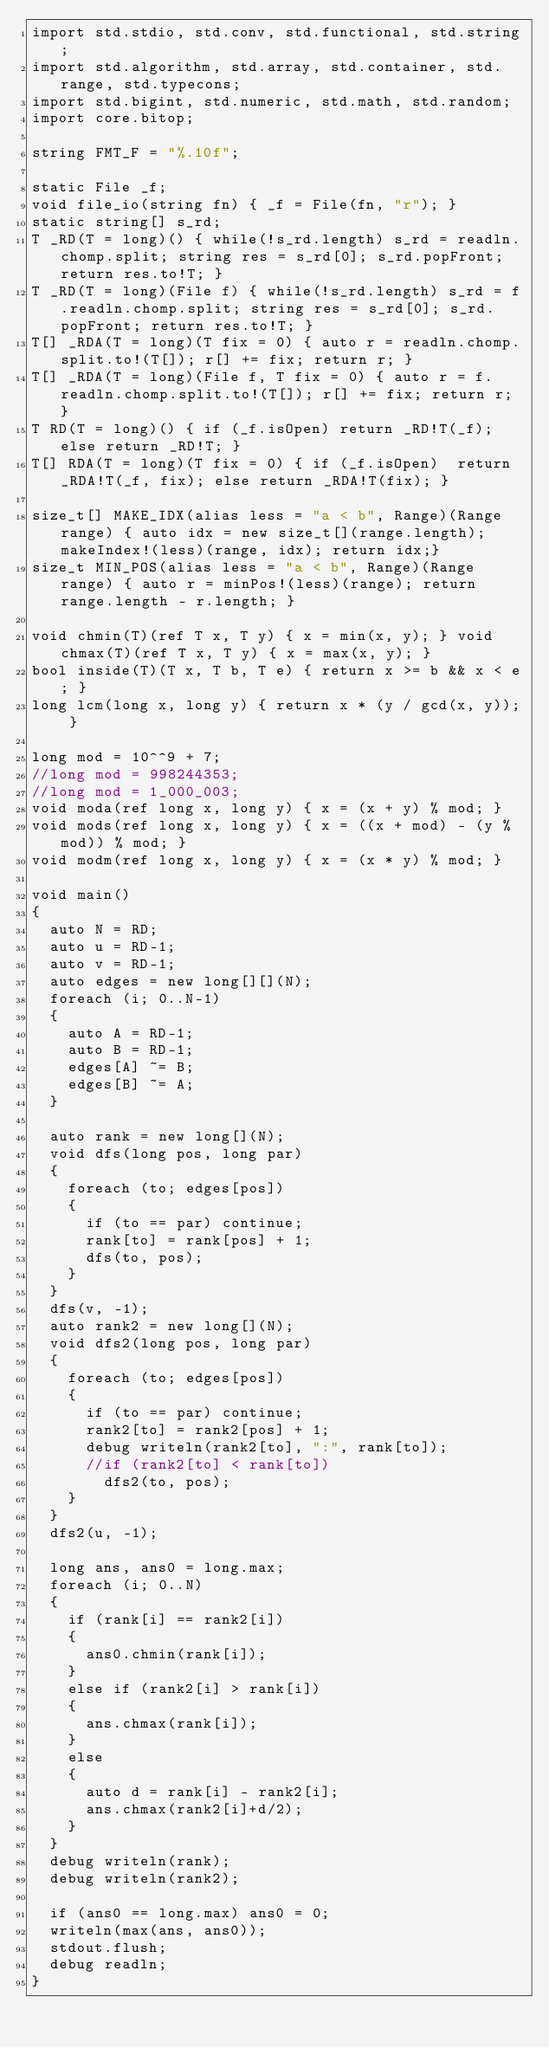Convert code to text. <code><loc_0><loc_0><loc_500><loc_500><_D_>import std.stdio, std.conv, std.functional, std.string;
import std.algorithm, std.array, std.container, std.range, std.typecons;
import std.bigint, std.numeric, std.math, std.random;
import core.bitop;

string FMT_F = "%.10f";

static File _f;
void file_io(string fn) { _f = File(fn, "r"); }
static string[] s_rd;
T _RD(T = long)() { while(!s_rd.length) s_rd = readln.chomp.split; string res = s_rd[0]; s_rd.popFront; return res.to!T; }
T _RD(T = long)(File f) { while(!s_rd.length) s_rd = f.readln.chomp.split; string res = s_rd[0]; s_rd.popFront; return res.to!T; }
T[] _RDA(T = long)(T fix = 0) { auto r = readln.chomp.split.to!(T[]); r[] += fix; return r; }
T[] _RDA(T = long)(File f, T fix = 0) { auto r = f.readln.chomp.split.to!(T[]); r[] += fix; return r; }
T RD(T = long)() { if (_f.isOpen) return _RD!T(_f); else return _RD!T; }
T[] RDA(T = long)(T fix = 0) { if (_f.isOpen)  return _RDA!T(_f, fix); else return _RDA!T(fix); }

size_t[] MAKE_IDX(alias less = "a < b", Range)(Range range) { auto idx = new size_t[](range.length); makeIndex!(less)(range, idx); return idx;}
size_t MIN_POS(alias less = "a < b", Range)(Range range) { auto r = minPos!(less)(range); return range.length - r.length; }

void chmin(T)(ref T x, T y) { x = min(x, y); } void chmax(T)(ref T x, T y) { x = max(x, y); }
bool inside(T)(T x, T b, T e) { return x >= b && x < e; }
long lcm(long x, long y) { return x * (y / gcd(x, y)); }

long mod = 10^^9 + 7;
//long mod = 998244353;
//long mod = 1_000_003;
void moda(ref long x, long y) { x = (x + y) % mod; }
void mods(ref long x, long y) { x = ((x + mod) - (y % mod)) % mod; }
void modm(ref long x, long y) { x = (x * y) % mod; }

void main()
{
	auto N = RD;
	auto u = RD-1;
	auto v = RD-1;
	auto edges = new long[][](N);
	foreach (i; 0..N-1)
	{
		auto A = RD-1;
		auto B = RD-1;
		edges[A] ~= B;
		edges[B] ~= A;
	}

	auto rank = new long[](N);
	void dfs(long pos, long par)
	{
		foreach (to; edges[pos])
		{
			if (to == par) continue;
			rank[to] = rank[pos] + 1;
			dfs(to, pos);
		}
	}
	dfs(v, -1);
	auto rank2 = new long[](N);
	void dfs2(long pos, long par)
	{
		foreach (to; edges[pos])
		{
			if (to == par) continue;
			rank2[to] = rank2[pos] + 1;
			debug writeln(rank2[to], ":", rank[to]);
			//if (rank2[to] < rank[to])
				dfs2(to, pos);
		}
	}
	dfs2(u, -1);
	
	long ans, ans0 = long.max;
	foreach (i; 0..N)
	{
		if (rank[i] == rank2[i])
		{
			ans0.chmin(rank[i]);
		}
		else if (rank2[i] > rank[i])
		{
			ans.chmax(rank[i]);
		}
		else
		{
			auto d = rank[i] - rank2[i];
			ans.chmax(rank2[i]+d/2);
		}
	}
	debug writeln(rank);
	debug writeln(rank2);

	if (ans0 == long.max) ans0 = 0;
	writeln(max(ans, ans0));
	stdout.flush;
	debug readln;
}</code> 